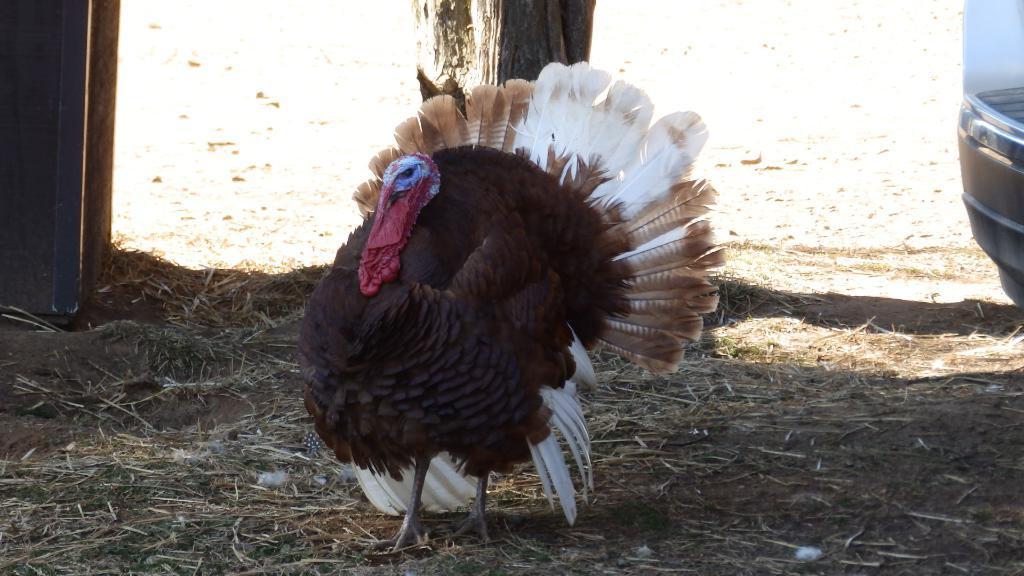How would you summarize this image in a sentence or two? In the picture a bird is standing on the ground. In the background I can see a tree and some other objects on the ground. 